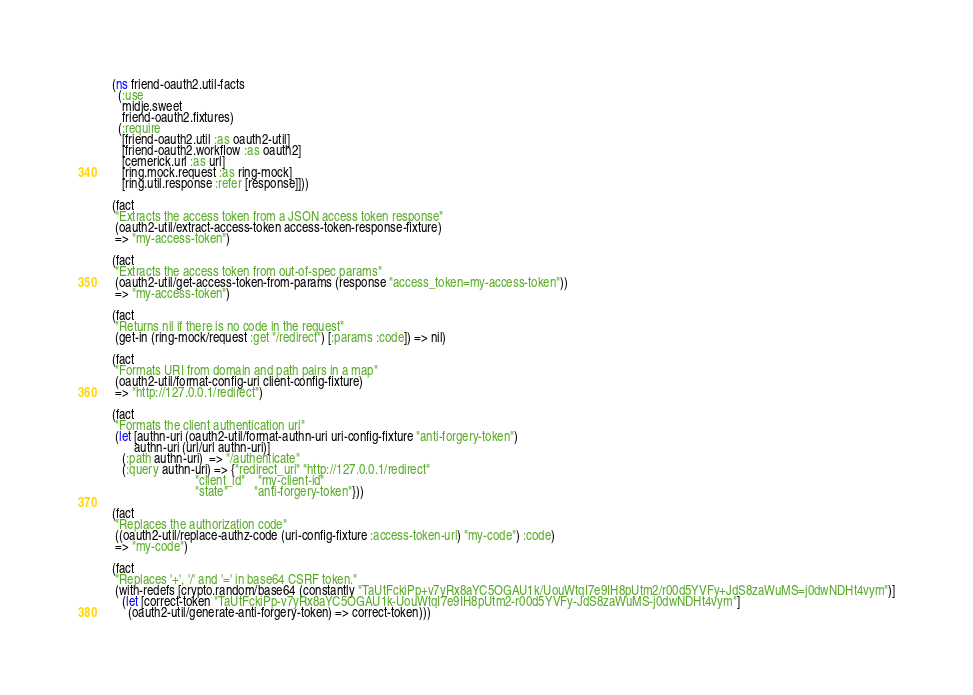<code> <loc_0><loc_0><loc_500><loc_500><_Clojure_>(ns friend-oauth2.util-facts
  (:use
   midje.sweet
   friend-oauth2.fixtures)
  (:require
   [friend-oauth2.util :as oauth2-util]
   [friend-oauth2.workflow :as oauth2]
   [cemerick.url :as url]
   [ring.mock.request :as ring-mock]
   [ring.util.response :refer [response]]))

(fact
 "Extracts the access token from a JSON access token response"
 (oauth2-util/extract-access-token access-token-response-fixture)
 => "my-access-token")

(fact
 "Extracts the access token from out-of-spec params"
 (oauth2-util/get-access-token-from-params (response "access_token=my-access-token"))
 => "my-access-token")

(fact
 "Returns nil if there is no code in the request"
 (get-in (ring-mock/request :get "/redirect") [:params :code]) => nil)

(fact
 "Formats URI from domain and path pairs in a map"
 (oauth2-util/format-config-uri client-config-fixture)
 => "http://127.0.0.1/redirect")

(fact
 "Formats the client authentication uri"
 (let [authn-uri (oauth2-util/format-authn-uri uri-config-fixture "anti-forgery-token")
       authn-uri (url/url authn-uri)]
   (:path authn-uri)  => "/authenticate"
   (:query authn-uri) => {"redirect_uri" "http://127.0.0.1/redirect"
                          "client_id"    "my-client-id"
                          "state"        "anti-forgery-token"}))

(fact
 "Replaces the authorization code"
 ((oauth2-util/replace-authz-code (uri-config-fixture :access-token-uri) "my-code") :code)
 => "my-code")

(fact
 "Replaces '+', '/' and '=' in base64 CSRF token."
 (with-redefs [crypto.random/base64 (constantly "TaUtFckiPp+v7yRx8aYC5OGAU1k/UouWtqI7e9IH8pUtm2/r00d5YVFy+JdS8zaWuMS=j0dwNDHt4vym")]
   (let [correct-token "TaUtFckiPp-v7yRx8aYC5OGAU1k-UouWtqI7e9IH8pUtm2-r00d5YVFy-JdS8zaWuMS-j0dwNDHt4vym"]
     (oauth2-util/generate-anti-forgery-token) => correct-token)))
</code> 